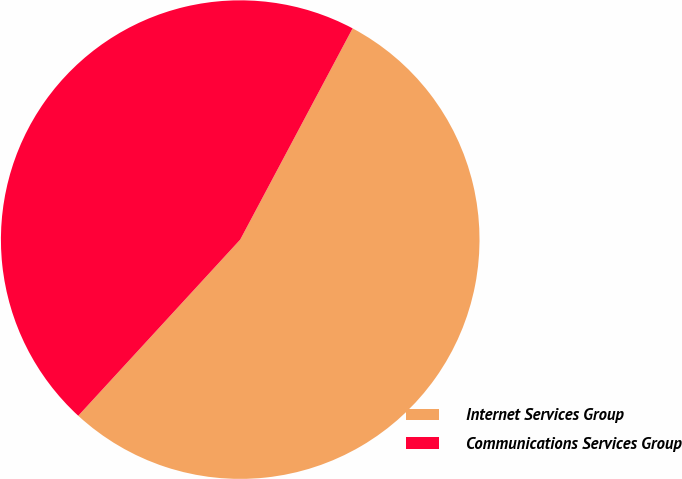Convert chart to OTSL. <chart><loc_0><loc_0><loc_500><loc_500><pie_chart><fcel>Internet Services Group<fcel>Communications Services Group<nl><fcel>54.05%<fcel>45.95%<nl></chart> 